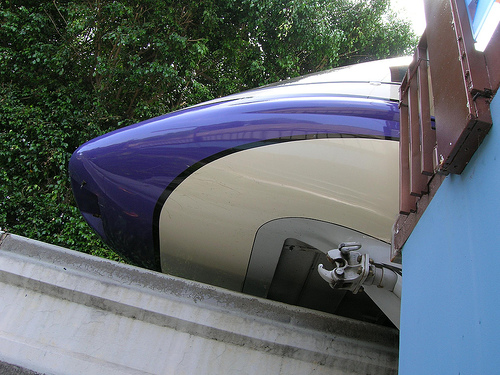<image>
Can you confirm if the train is on the wall? No. The train is not positioned on the wall. They may be near each other, but the train is not supported by or resting on top of the wall. 